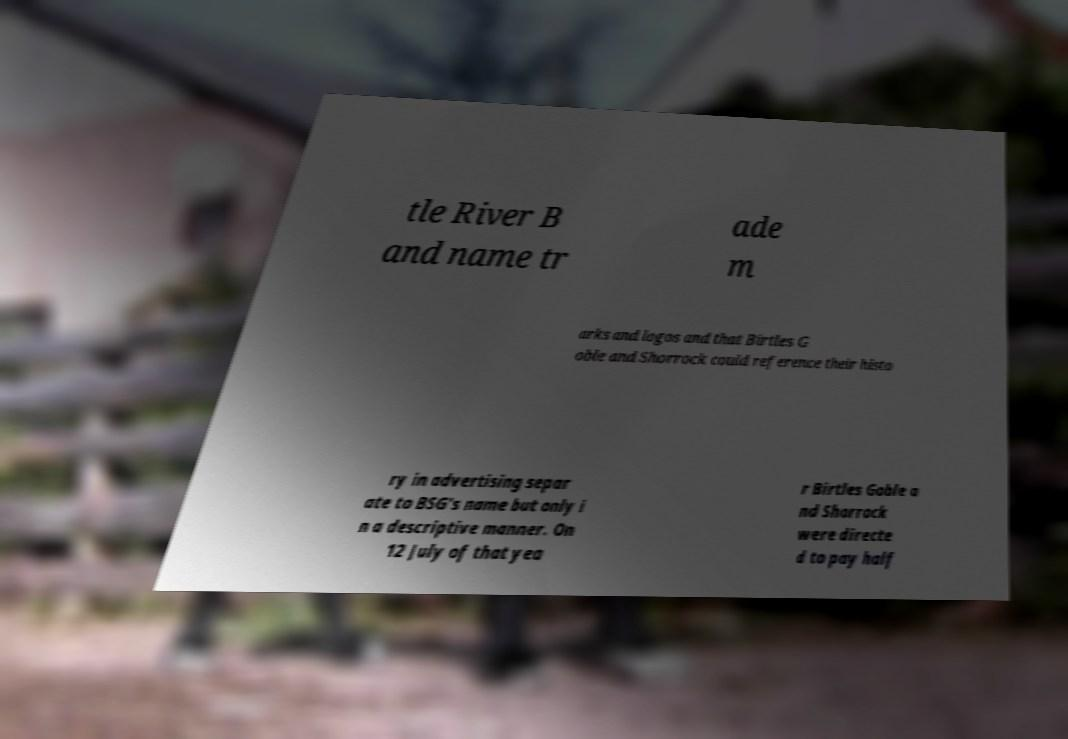Could you extract and type out the text from this image? tle River B and name tr ade m arks and logos and that Birtles G oble and Shorrock could reference their histo ry in advertising separ ate to BSG's name but only i n a descriptive manner. On 12 July of that yea r Birtles Goble a nd Shorrock were directe d to pay half 